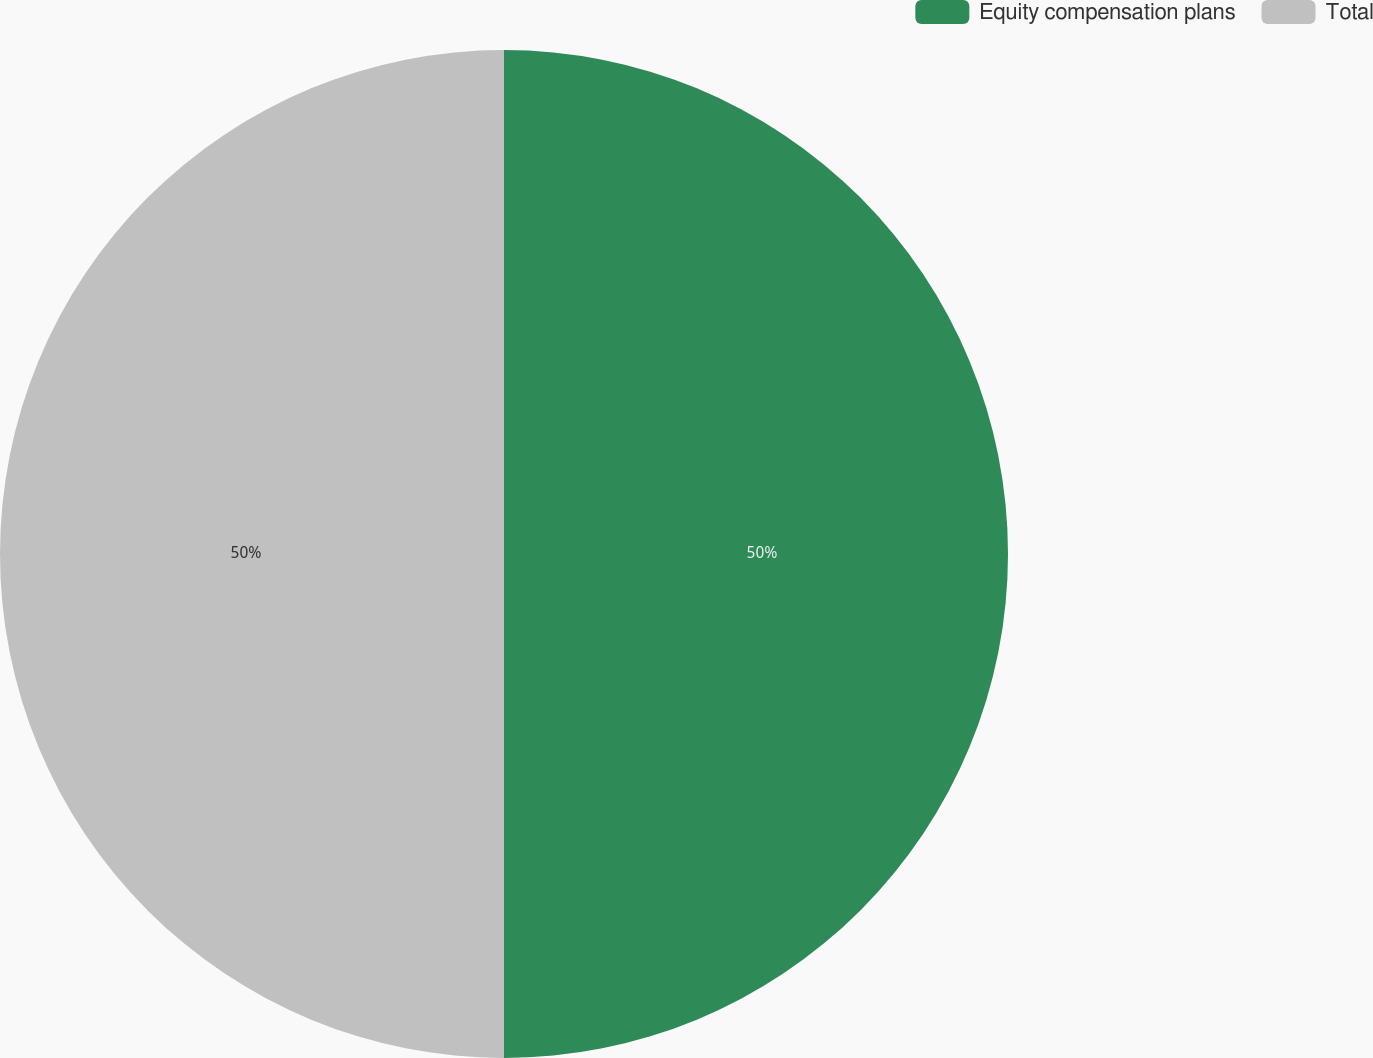<chart> <loc_0><loc_0><loc_500><loc_500><pie_chart><fcel>Equity compensation plans<fcel>Total<nl><fcel>50.0%<fcel>50.0%<nl></chart> 